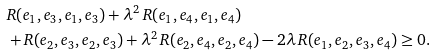<formula> <loc_0><loc_0><loc_500><loc_500>& R ( e _ { 1 } , e _ { 3 } , e _ { 1 } , e _ { 3 } ) + \lambda ^ { 2 } \, R ( e _ { 1 } , e _ { 4 } , e _ { 1 } , e _ { 4 } ) \\ & + R ( e _ { 2 } , e _ { 3 } , e _ { 2 } , e _ { 3 } ) + \lambda ^ { 2 } \, R ( e _ { 2 } , e _ { 4 } , e _ { 2 } , e _ { 4 } ) - 2 \lambda \, R ( e _ { 1 } , e _ { 2 } , e _ { 3 } , e _ { 4 } ) \geq 0 .</formula> 